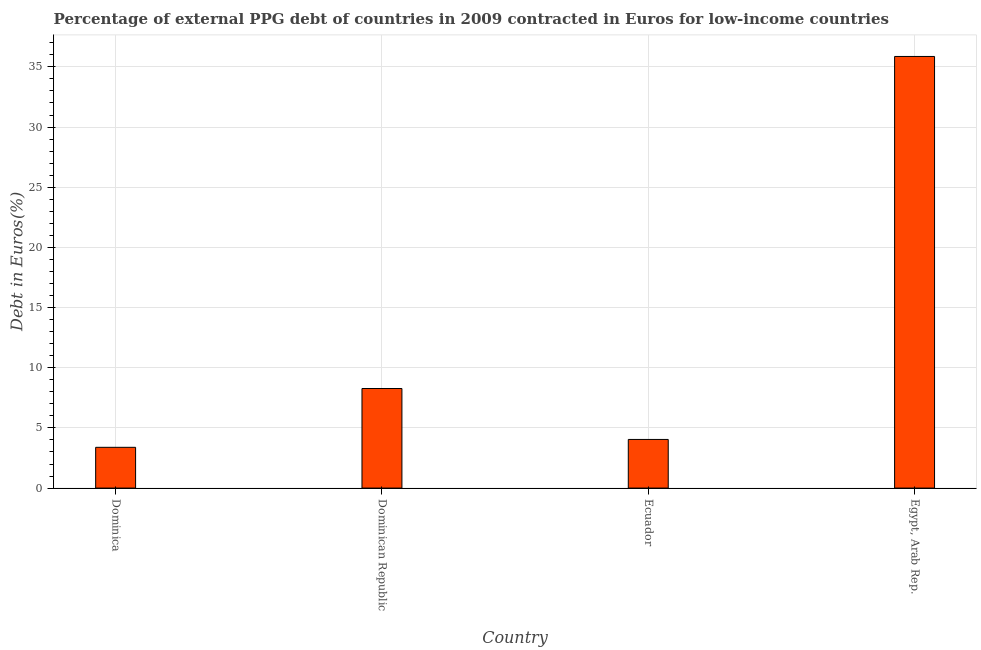Does the graph contain any zero values?
Make the answer very short. No. What is the title of the graph?
Ensure brevity in your answer.  Percentage of external PPG debt of countries in 2009 contracted in Euros for low-income countries. What is the label or title of the Y-axis?
Provide a short and direct response. Debt in Euros(%). What is the currency composition of ppg debt in Egypt, Arab Rep.?
Provide a succinct answer. 35.87. Across all countries, what is the maximum currency composition of ppg debt?
Ensure brevity in your answer.  35.87. Across all countries, what is the minimum currency composition of ppg debt?
Provide a short and direct response. 3.39. In which country was the currency composition of ppg debt maximum?
Your response must be concise. Egypt, Arab Rep. In which country was the currency composition of ppg debt minimum?
Your response must be concise. Dominica. What is the sum of the currency composition of ppg debt?
Provide a succinct answer. 51.57. What is the difference between the currency composition of ppg debt in Dominica and Egypt, Arab Rep.?
Your response must be concise. -32.48. What is the average currency composition of ppg debt per country?
Your answer should be compact. 12.89. What is the median currency composition of ppg debt?
Your answer should be compact. 6.16. In how many countries, is the currency composition of ppg debt greater than 20 %?
Provide a short and direct response. 1. What is the ratio of the currency composition of ppg debt in Dominican Republic to that in Egypt, Arab Rep.?
Give a very brief answer. 0.23. Is the currency composition of ppg debt in Dominica less than that in Ecuador?
Your answer should be compact. Yes. What is the difference between the highest and the second highest currency composition of ppg debt?
Provide a short and direct response. 27.59. What is the difference between the highest and the lowest currency composition of ppg debt?
Your answer should be compact. 32.48. How many bars are there?
Your answer should be compact. 4. Are all the bars in the graph horizontal?
Keep it short and to the point. No. How many countries are there in the graph?
Provide a short and direct response. 4. What is the Debt in Euros(%) in Dominica?
Make the answer very short. 3.39. What is the Debt in Euros(%) of Dominican Republic?
Give a very brief answer. 8.28. What is the Debt in Euros(%) of Ecuador?
Provide a succinct answer. 4.04. What is the Debt in Euros(%) of Egypt, Arab Rep.?
Your answer should be very brief. 35.87. What is the difference between the Debt in Euros(%) in Dominica and Dominican Republic?
Keep it short and to the point. -4.89. What is the difference between the Debt in Euros(%) in Dominica and Ecuador?
Provide a succinct answer. -0.66. What is the difference between the Debt in Euros(%) in Dominica and Egypt, Arab Rep.?
Your response must be concise. -32.48. What is the difference between the Debt in Euros(%) in Dominican Republic and Ecuador?
Make the answer very short. 4.23. What is the difference between the Debt in Euros(%) in Dominican Republic and Egypt, Arab Rep.?
Your answer should be very brief. -27.59. What is the difference between the Debt in Euros(%) in Ecuador and Egypt, Arab Rep.?
Provide a succinct answer. -31.82. What is the ratio of the Debt in Euros(%) in Dominica to that in Dominican Republic?
Your answer should be compact. 0.41. What is the ratio of the Debt in Euros(%) in Dominica to that in Ecuador?
Your answer should be compact. 0.84. What is the ratio of the Debt in Euros(%) in Dominica to that in Egypt, Arab Rep.?
Provide a succinct answer. 0.09. What is the ratio of the Debt in Euros(%) in Dominican Republic to that in Ecuador?
Keep it short and to the point. 2.05. What is the ratio of the Debt in Euros(%) in Dominican Republic to that in Egypt, Arab Rep.?
Make the answer very short. 0.23. What is the ratio of the Debt in Euros(%) in Ecuador to that in Egypt, Arab Rep.?
Ensure brevity in your answer.  0.11. 